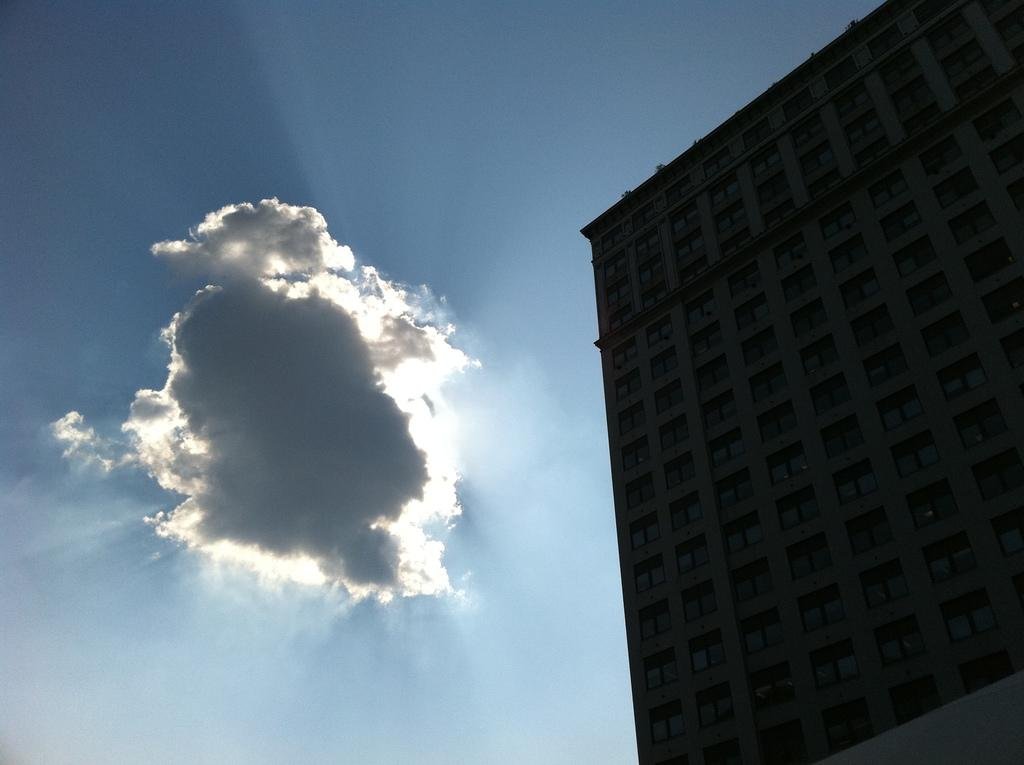What can be seen at the top of the image? The sky is visible in the image. What type of structure is located on the right side of the image? There is a building on the right side of the image. What type of ice can be seen melting on the spoon in the image? There is no ice or spoon present in the image. What is the building used for in the image? The purpose of the building cannot be determined from the image alone. 